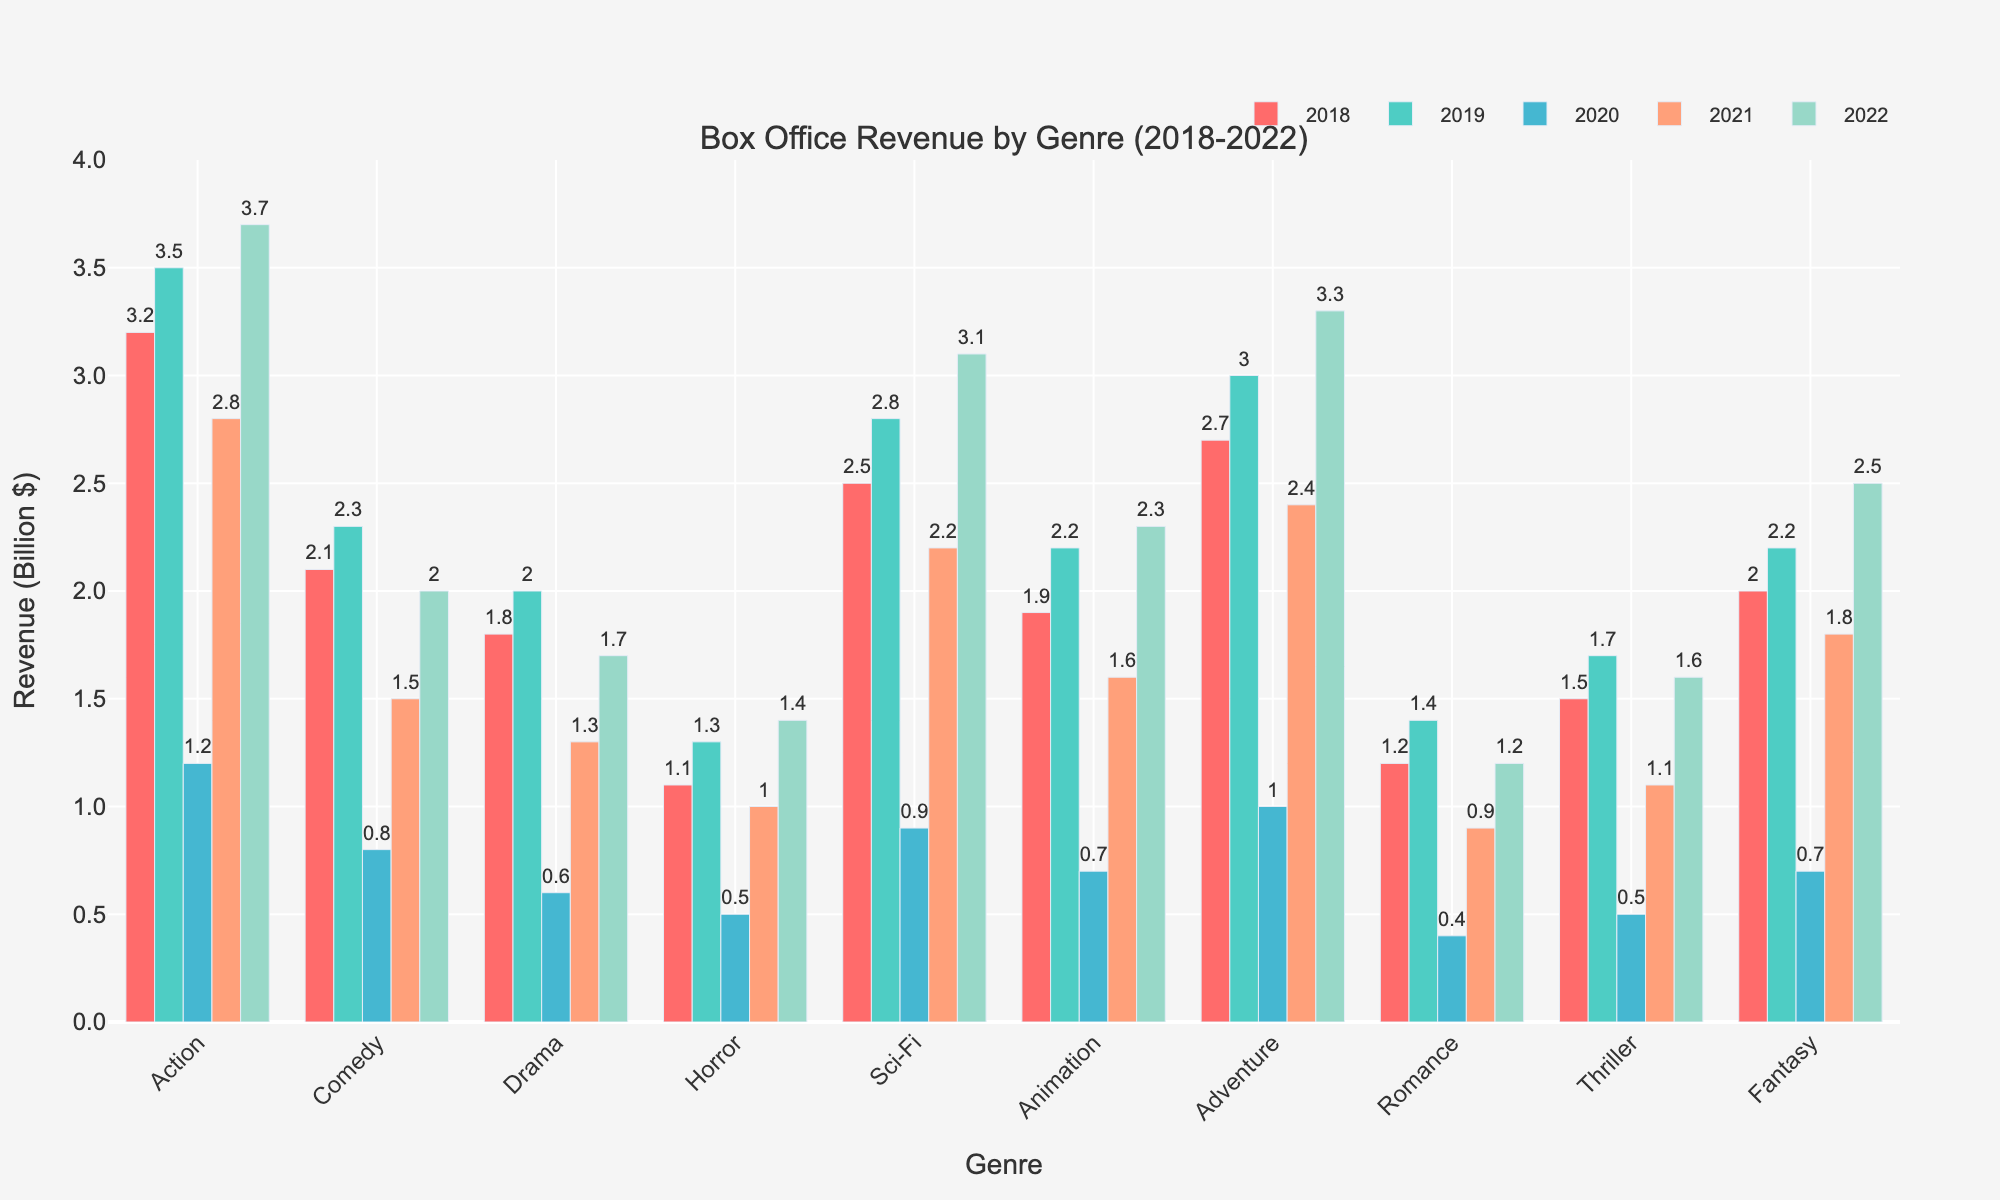What is the total box office revenue for the Action genre over the past 5 years? Sum the revenues for Action from each year: 3.2 (2018) + 3.5 (2019) + 1.2 (2020) + 2.8 (2021) + 3.7 (2022).
Answer: 14.4 billion dollars Which genre had the highest revenue in 2022? Compare the heights of the bars for 2022. The Action genre has the tallest bar in 2022.
Answer: Action How did the revenue for Adventure change between 2020 and 2021? Subtract the 2020 revenue for Adventure from the 2021 revenue: 2.4 (2021) - 1.0 (2020).
Answer: Increased by 1.4 billion dollars Which year had the lowest overall box office revenue across all genres? Add up the revenues for each year and compare. 2020 has the lowest sum: (1.2 + 0.8 + 0.6 + 0.5 + 0.9 + 0.7 + 1.0 + 0.4 + 0.5 + 0.7) = 7.3.
Answer: 2020 What is the average revenue of the Comedy genre over the 5-year period? Sum the revenues for Comedy and divide by 5: (2.1 + 2.3 + 0.8 + 1.5 + 2.0) / 5 = 8.7 / 5.
Answer: 1.74 billion dollars Did the Sci-Fi genre see an increase or decrease in revenue from 2019 to 2022? Compare the bars for Sci-Fi in 2019 and 2022. 2022's bar has a higher value (3.1) than 2019's (2.8).
Answer: Increase Which genre consistently had a revenue of 2 billion dollars or more every year? Check the heights of the bars and identify the genre(s) meeting the criteria. No genre meets this criterion consistently every year.
Answer: None In which year did the Drama genre see the largest drop in revenue compared to the previous year? Find the differences year-to-year for Drama: 2.0 (2019) - 1.8 (2018) = 0.2, 0.6 (2020) - 2.0 (2019) = -1.4, 1.3 (2021) - 0.6 (2020) = 0.7, 1.7 (2022) - 1.3 (2021) = 0.4. The largest drop is between 2019 and 2020.
Answer: Between 2019 and 2020 Which two genres had the closest revenues in 2021? Compare the heights of the bars for 2021. Thriller (1.1) and Horror (1.0) have the closest values.
Answer: Thriller and Horror 